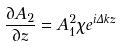<formula> <loc_0><loc_0><loc_500><loc_500>\frac { \partial A _ { 2 } } { \partial z } = A _ { 1 } ^ { 2 } \chi e ^ { i \Delta k z }</formula> 